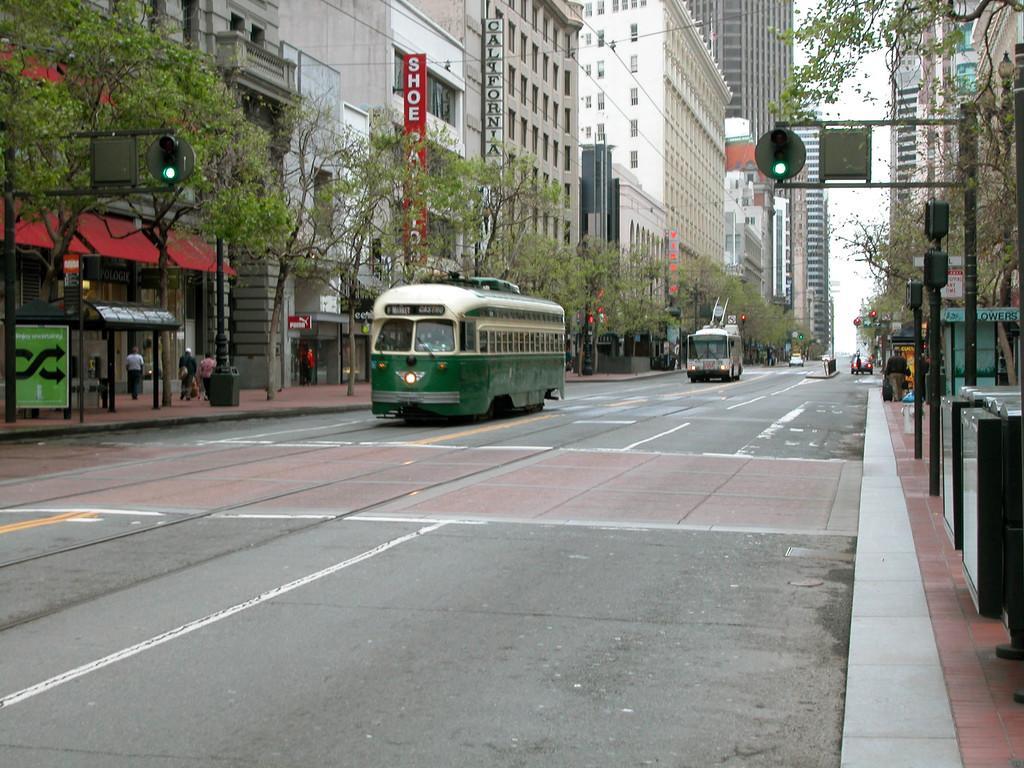Describe this image in one or two sentences. There are vehicles on the road. Here we can see trees, poles, boards, and few persons. There are buildings. In the background we can see sky. 